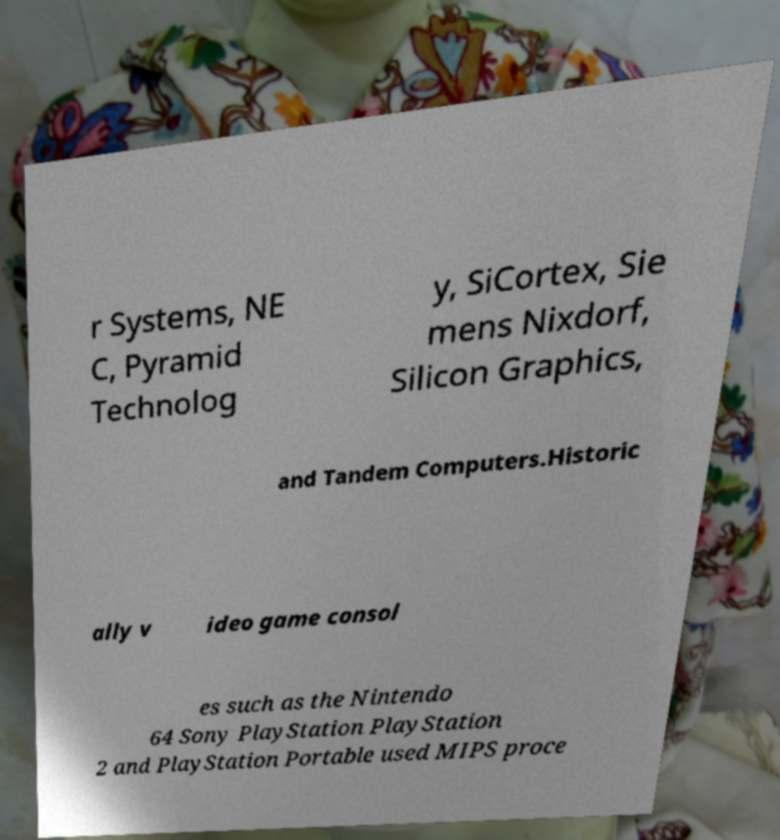Can you accurately transcribe the text from the provided image for me? r Systems, NE C, Pyramid Technolog y, SiCortex, Sie mens Nixdorf, Silicon Graphics, and Tandem Computers.Historic ally v ideo game consol es such as the Nintendo 64 Sony PlayStation PlayStation 2 and PlayStation Portable used MIPS proce 